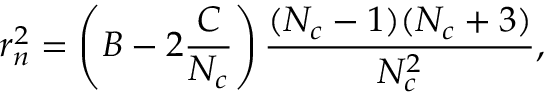Convert formula to latex. <formula><loc_0><loc_0><loc_500><loc_500>r _ { n } ^ { 2 } = \left ( B - 2 \frac { C } { N _ { c } } \right ) \frac { ( N _ { c } - 1 ) ( N _ { c } + 3 ) } { N _ { c } ^ { 2 } } ,</formula> 